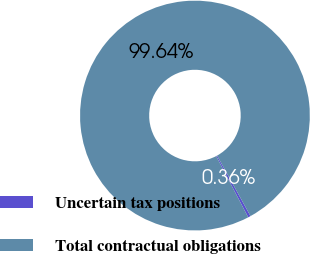<chart> <loc_0><loc_0><loc_500><loc_500><pie_chart><fcel>Uncertain tax positions<fcel>Total contractual obligations<nl><fcel>0.36%<fcel>99.64%<nl></chart> 